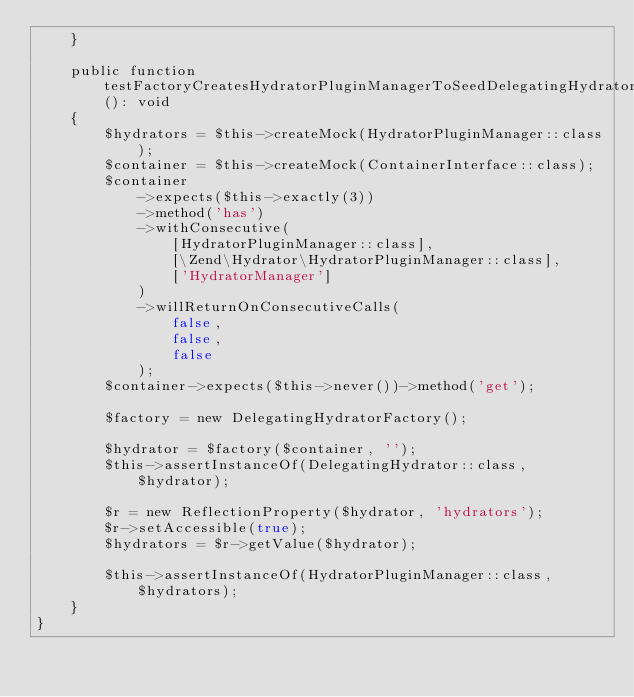Convert code to text. <code><loc_0><loc_0><loc_500><loc_500><_PHP_>    }

    public function testFactoryCreatesHydratorPluginManagerToSeedDelegatingHydratorAsFallback(): void
    {
        $hydrators = $this->createMock(HydratorPluginManager::class);
        $container = $this->createMock(ContainerInterface::class);
        $container
            ->expects($this->exactly(3))
            ->method('has')
            ->withConsecutive(
                [HydratorPluginManager::class],
                [\Zend\Hydrator\HydratorPluginManager::class],
                ['HydratorManager']
            )
            ->willReturnOnConsecutiveCalls(
                false,
                false,
                false
            );
        $container->expects($this->never())->method('get');

        $factory = new DelegatingHydratorFactory();

        $hydrator = $factory($container, '');
        $this->assertInstanceOf(DelegatingHydrator::class, $hydrator);

        $r = new ReflectionProperty($hydrator, 'hydrators');
        $r->setAccessible(true);
        $hydrators = $r->getValue($hydrator);

        $this->assertInstanceOf(HydratorPluginManager::class, $hydrators);
    }
}
</code> 